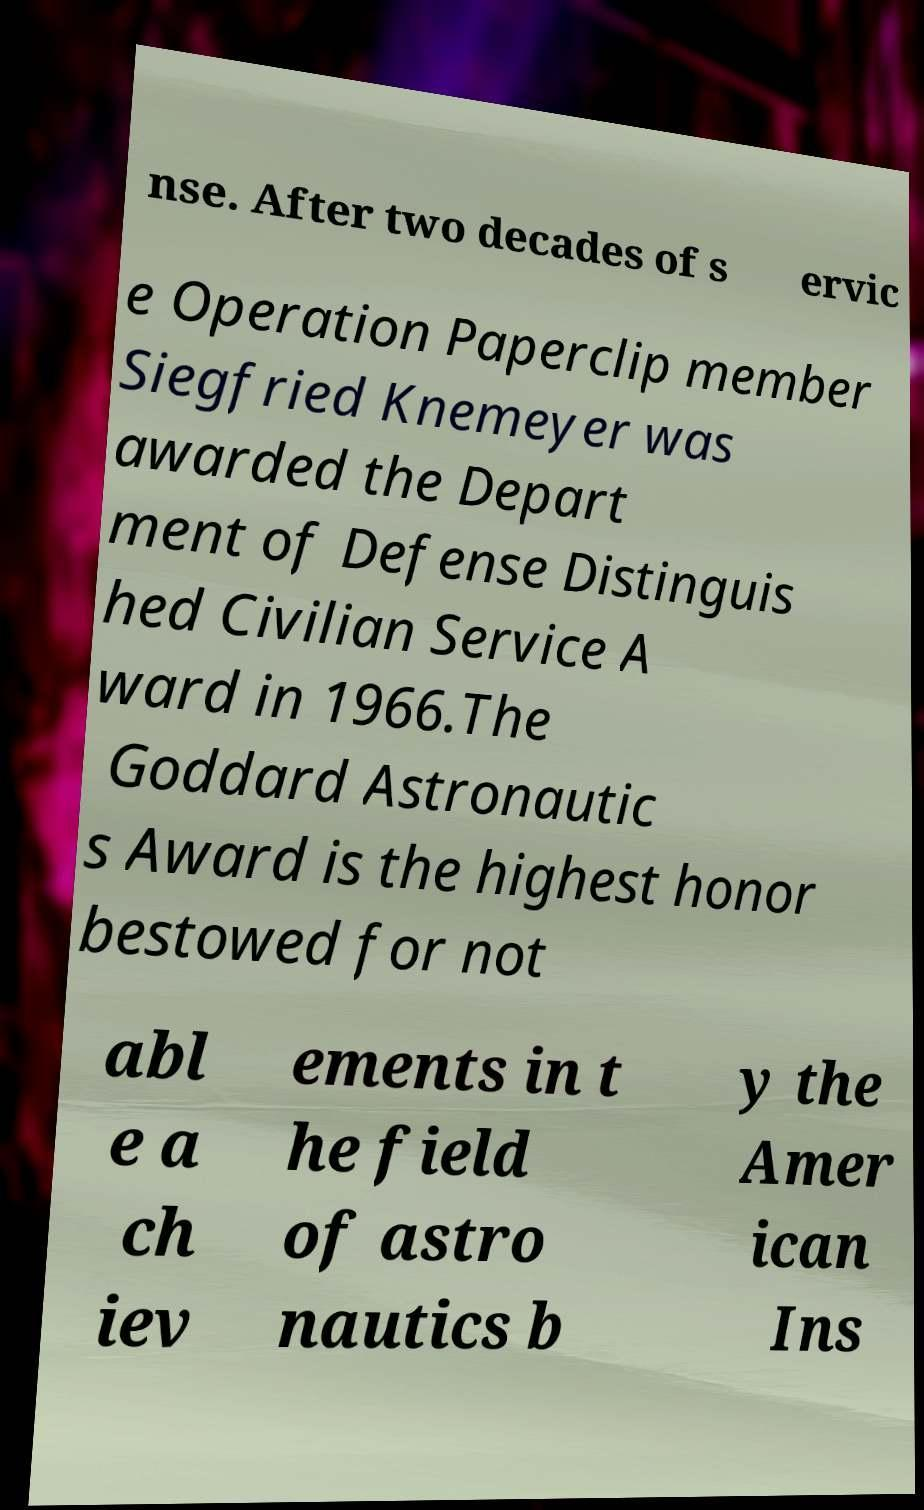Please identify and transcribe the text found in this image. nse. After two decades of s ervic e Operation Paperclip member Siegfried Knemeyer was awarded the Depart ment of Defense Distinguis hed Civilian Service A ward in 1966.The Goddard Astronautic s Award is the highest honor bestowed for not abl e a ch iev ements in t he field of astro nautics b y the Amer ican Ins 